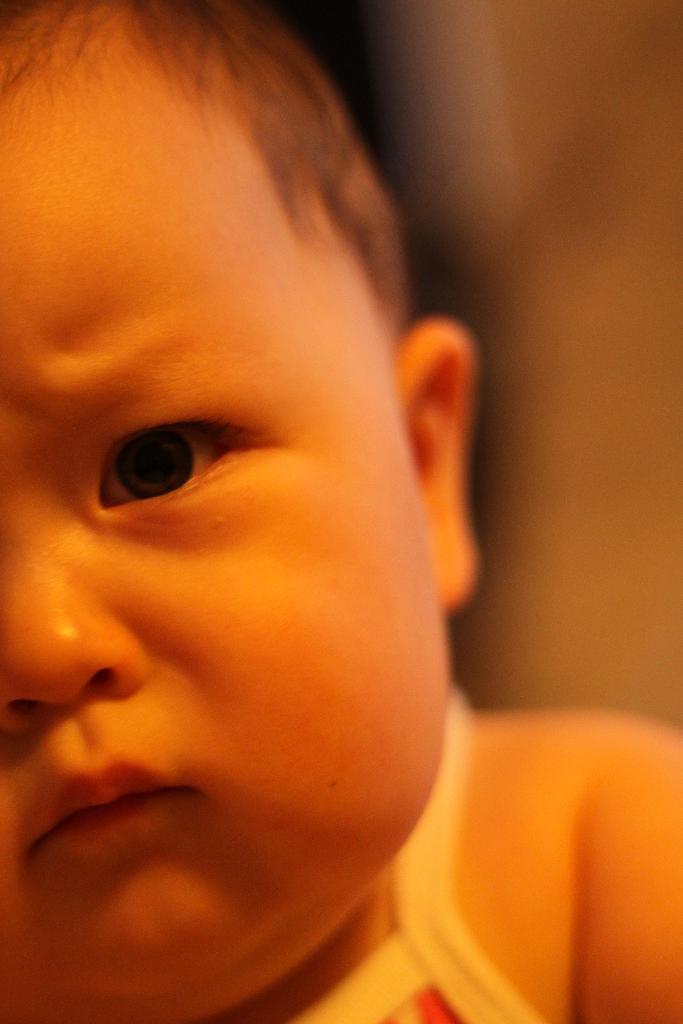How would you summarize this image in a sentence or two? In the image we can see a close up pic of a baby, wearing clothes and the background is blurred. 